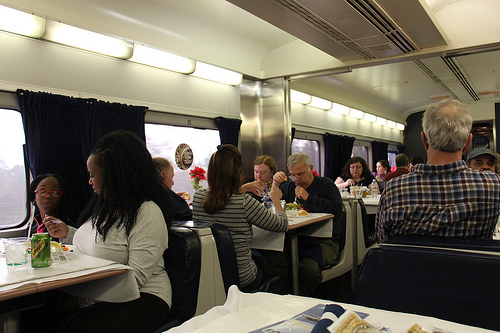<image>
Can you confirm if the woman is in the booth seat? No. The woman is not contained within the booth seat. These objects have a different spatial relationship. 